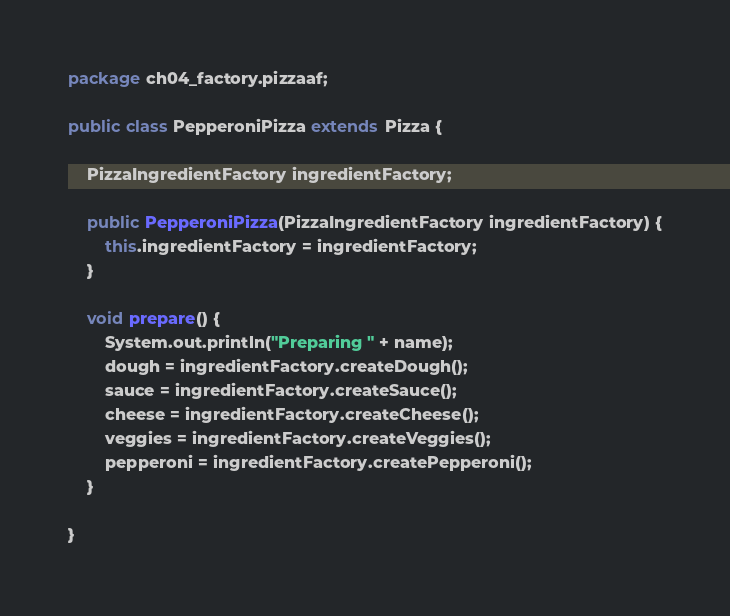Convert code to text. <code><loc_0><loc_0><loc_500><loc_500><_Java_>package ch04_factory.pizzaaf;

public class PepperoniPizza extends Pizza {

	PizzaIngredientFactory ingredientFactory;

	public PepperoniPizza(PizzaIngredientFactory ingredientFactory) {
		this.ingredientFactory = ingredientFactory;
	}

	void prepare() {
		System.out.println("Preparing " + name);
		dough = ingredientFactory.createDough();
		sauce = ingredientFactory.createSauce();
		cheese = ingredientFactory.createCheese();
		veggies = ingredientFactory.createVeggies();
		pepperoni = ingredientFactory.createPepperoni();
	}

}
</code> 